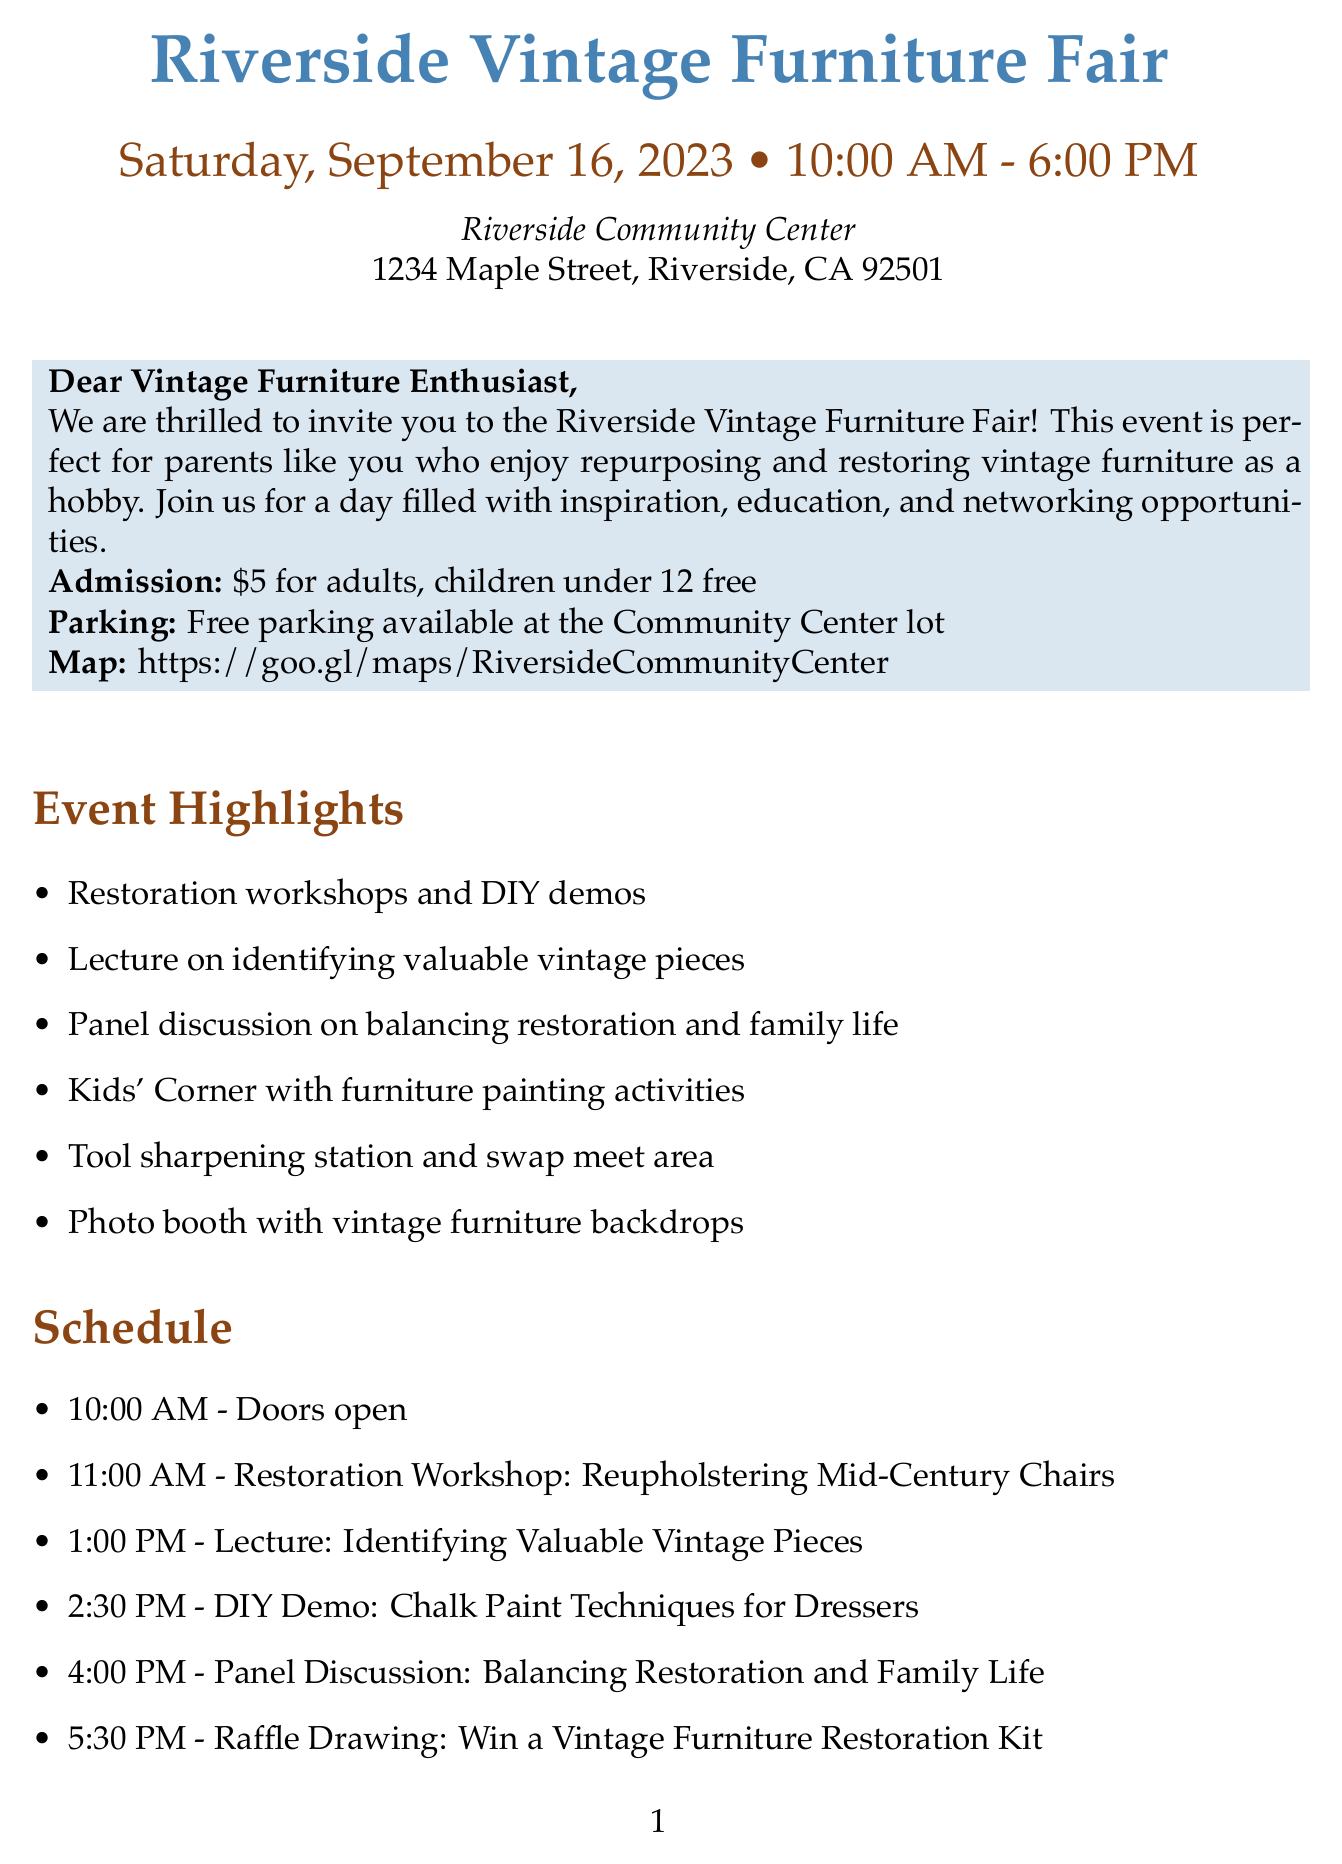What is the name of the event? The name of the event is stated at the top of the document as the Riverside Vintage Furniture Fair.
Answer: Riverside Vintage Furniture Fair When does the event take place? The date of the event is explicitly mentioned in the document, which is Saturday, September 16, 2023.
Answer: Saturday, September 16, 2023 What is the admission fee for adults? The document specifies that the admission fee for adults is $5.
Answer: $5 Who is the presenter of the restoration workshop? The name of the presenter for the restoration workshop is given in the schedule as Sarah Johnson.
Answer: Sarah Johnson What is one of the special features mentioned for children? The document highlights a special feature called Kids' Corner that offers furniture painting activities for children.
Answer: Kids' Corner What time does the doors open? The schedule states that the doors open at 10:00 AM.
Answer: 10:00 AM Which vendor specializes in eco-friendly products? The document lists Green Rabbit Paints as the vendor specializing in eco-friendly furniture paints and finishes.
Answer: Green Rabbit Paints What is included in the contact information section? The contact information section provides the name of the event coordinator, Jessica Thompson, and her contact details.
Answer: Jessica Thompson What type of discussion is scheduled for 4:00 PM? The schedule lists a panel discussion focused on balancing restoration and family life.
Answer: Panel Discussion: Balancing Restoration and Family Life 